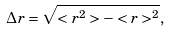<formula> <loc_0><loc_0><loc_500><loc_500>\Delta r = \sqrt { < r ^ { 2 } > - < r > ^ { 2 } } ,</formula> 